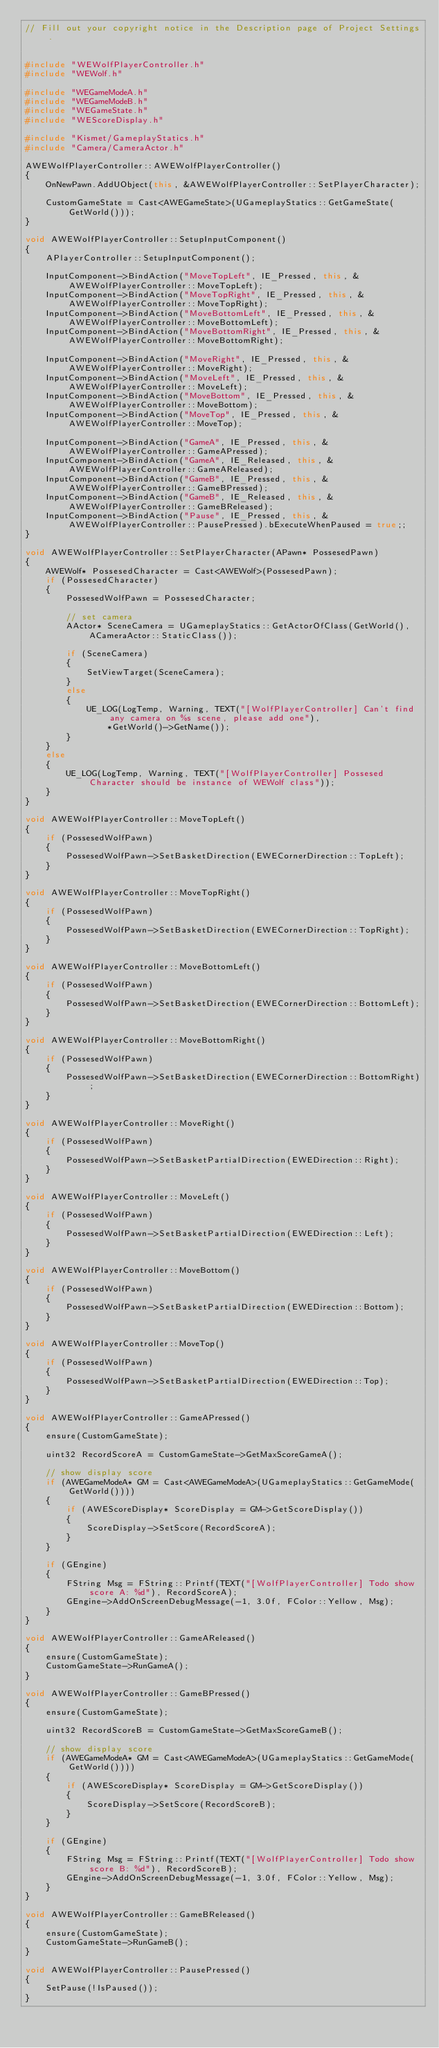Convert code to text. <code><loc_0><loc_0><loc_500><loc_500><_C++_>// Fill out your copyright notice in the Description page of Project Settings.


#include "WEWolfPlayerController.h"
#include "WEWolf.h"

#include "WEGameModeA.h"
#include "WEGameModeB.h"
#include "WEGameState.h"
#include "WEScoreDisplay.h"

#include "Kismet/GameplayStatics.h"
#include "Camera/CameraActor.h"

AWEWolfPlayerController::AWEWolfPlayerController()
{
	OnNewPawn.AddUObject(this, &AWEWolfPlayerController::SetPlayerCharacter);

	CustomGameState = Cast<AWEGameState>(UGameplayStatics::GetGameState(GetWorld()));
}

void AWEWolfPlayerController::SetupInputComponent()
{
	APlayerController::SetupInputComponent();

	InputComponent->BindAction("MoveTopLeft", IE_Pressed, this, &AWEWolfPlayerController::MoveTopLeft);
	InputComponent->BindAction("MoveTopRight", IE_Pressed, this, &AWEWolfPlayerController::MoveTopRight);
	InputComponent->BindAction("MoveBottomLeft", IE_Pressed, this, &AWEWolfPlayerController::MoveBottomLeft);
	InputComponent->BindAction("MoveBottomRight", IE_Pressed, this, &AWEWolfPlayerController::MoveBottomRight);

	InputComponent->BindAction("MoveRight", IE_Pressed, this, &AWEWolfPlayerController::MoveRight);
	InputComponent->BindAction("MoveLeft", IE_Pressed, this, &AWEWolfPlayerController::MoveLeft);
	InputComponent->BindAction("MoveBottom", IE_Pressed, this, &AWEWolfPlayerController::MoveBottom);
	InputComponent->BindAction("MoveTop", IE_Pressed, this, &AWEWolfPlayerController::MoveTop);

	InputComponent->BindAction("GameA", IE_Pressed, this, &AWEWolfPlayerController::GameAPressed);
	InputComponent->BindAction("GameA", IE_Released, this, &AWEWolfPlayerController::GameAReleased);
	InputComponent->BindAction("GameB", IE_Pressed, this, &AWEWolfPlayerController::GameBPressed);
	InputComponent->BindAction("GameB", IE_Released, this, &AWEWolfPlayerController::GameBReleased);
	InputComponent->BindAction("Pause", IE_Pressed, this, &AWEWolfPlayerController::PausePressed).bExecuteWhenPaused = true;;
}

void AWEWolfPlayerController::SetPlayerCharacter(APawn* PossesedPawn)
{
	AWEWolf* PossesedCharacter = Cast<AWEWolf>(PossesedPawn);
	if (PossesedCharacter)
	{
		PossesedWolfPawn = PossesedCharacter;

		// set camera
		AActor* SceneCamera = UGameplayStatics::GetActorOfClass(GetWorld(), ACameraActor::StaticClass());

		if (SceneCamera)
		{
			SetViewTarget(SceneCamera);
		}
		else
		{
			UE_LOG(LogTemp, Warning, TEXT("[WolfPlayerController] Can't find any camera on %s scene, please add one"), 
				*GetWorld()->GetName());
		}
	}
	else
	{
		UE_LOG(LogTemp, Warning, TEXT("[WolfPlayerController] Possesed Character should be instance of WEWolf class"));
	}
}

void AWEWolfPlayerController::MoveTopLeft()
{
	if (PossesedWolfPawn)
	{
		PossesedWolfPawn->SetBasketDirection(EWECornerDirection::TopLeft);
	}
}

void AWEWolfPlayerController::MoveTopRight()
{
	if (PossesedWolfPawn)
	{
		PossesedWolfPawn->SetBasketDirection(EWECornerDirection::TopRight);
	}
}

void AWEWolfPlayerController::MoveBottomLeft()
{
	if (PossesedWolfPawn)
	{
		PossesedWolfPawn->SetBasketDirection(EWECornerDirection::BottomLeft);
	}
}

void AWEWolfPlayerController::MoveBottomRight()
{
	if (PossesedWolfPawn)
	{
		PossesedWolfPawn->SetBasketDirection(EWECornerDirection::BottomRight);
	}
}

void AWEWolfPlayerController::MoveRight()
{
	if (PossesedWolfPawn)
	{
		PossesedWolfPawn->SetBasketPartialDirection(EWEDirection::Right);
	}
}

void AWEWolfPlayerController::MoveLeft()
{
	if (PossesedWolfPawn)
	{
		PossesedWolfPawn->SetBasketPartialDirection(EWEDirection::Left);
	}
}

void AWEWolfPlayerController::MoveBottom()
{
	if (PossesedWolfPawn)
	{
		PossesedWolfPawn->SetBasketPartialDirection(EWEDirection::Bottom);
	}
}

void AWEWolfPlayerController::MoveTop()
{
	if (PossesedWolfPawn)
	{
		PossesedWolfPawn->SetBasketPartialDirection(EWEDirection::Top);
	}
}

void AWEWolfPlayerController::GameAPressed()
{
	ensure(CustomGameState);
	
	uint32 RecordScoreA = CustomGameState->GetMaxScoreGameA();

	// show display score
	if (AWEGameModeA* GM = Cast<AWEGameModeA>(UGameplayStatics::GetGameMode(GetWorld())))
	{
		if (AWEScoreDisplay* ScoreDisplay = GM->GetScoreDisplay())
		{
			ScoreDisplay->SetScore(RecordScoreA);
		}
	}

	if (GEngine)
	{
		FString Msg = FString::Printf(TEXT("[WolfPlayerController] Todo show score A: %d"), RecordScoreA);
		GEngine->AddOnScreenDebugMessage(-1, 3.0f, FColor::Yellow, Msg);
	}
}

void AWEWolfPlayerController::GameAReleased()
{
	ensure(CustomGameState);
	CustomGameState->RunGameA();
}

void AWEWolfPlayerController::GameBPressed()
{
	ensure(CustomGameState);

	uint32 RecordScoreB = CustomGameState->GetMaxScoreGameB();

	// show display score
	if (AWEGameModeA* GM = Cast<AWEGameModeA>(UGameplayStatics::GetGameMode(GetWorld())))
	{
		if (AWEScoreDisplay* ScoreDisplay = GM->GetScoreDisplay())
		{
			ScoreDisplay->SetScore(RecordScoreB);
		}
	}

	if (GEngine)
	{
		FString Msg = FString::Printf(TEXT("[WolfPlayerController] Todo show score B: %d"), RecordScoreB);
		GEngine->AddOnScreenDebugMessage(-1, 3.0f, FColor::Yellow, Msg);
	}
}

void AWEWolfPlayerController::GameBReleased()
{
	ensure(CustomGameState);
	CustomGameState->RunGameB();
}

void AWEWolfPlayerController::PausePressed()
{
	SetPause(!IsPaused());
}
</code> 